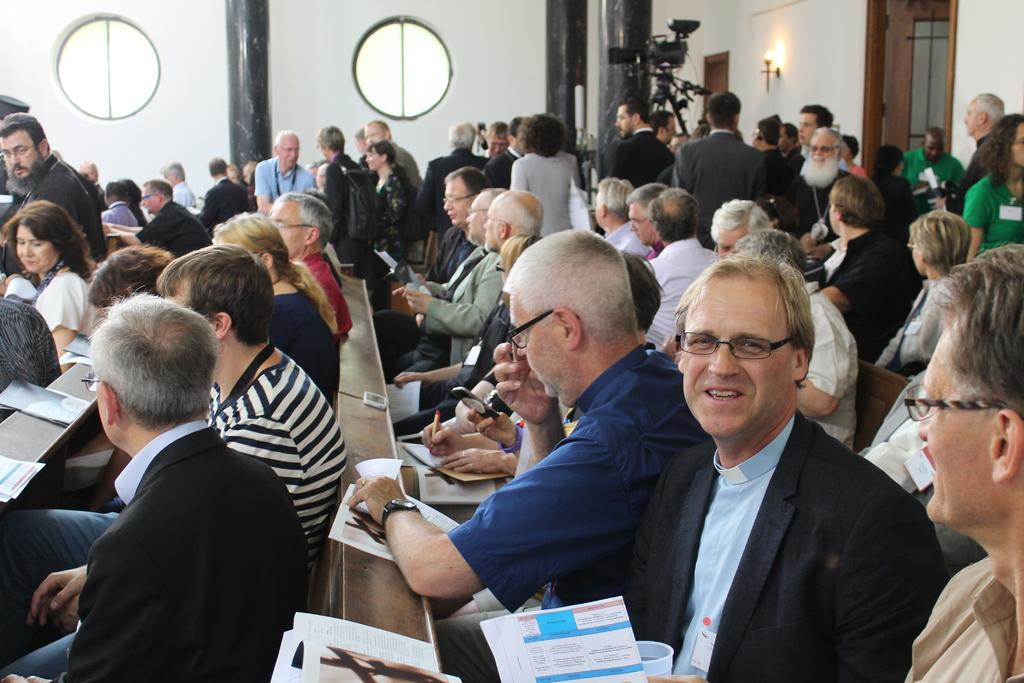How many people are in the image? There are many people in the image. What are the people doing in the image? The people are sitting in a hall and holding papers. What can be seen in the background of the image? There is a wall and pillars in the background of the image. Is there any equipment visible in the image? Yes, there is a camera visible to the right in the image. How are the people sorting the drain in the image? There is no drain present in the image, and the people are not sorting anything. 